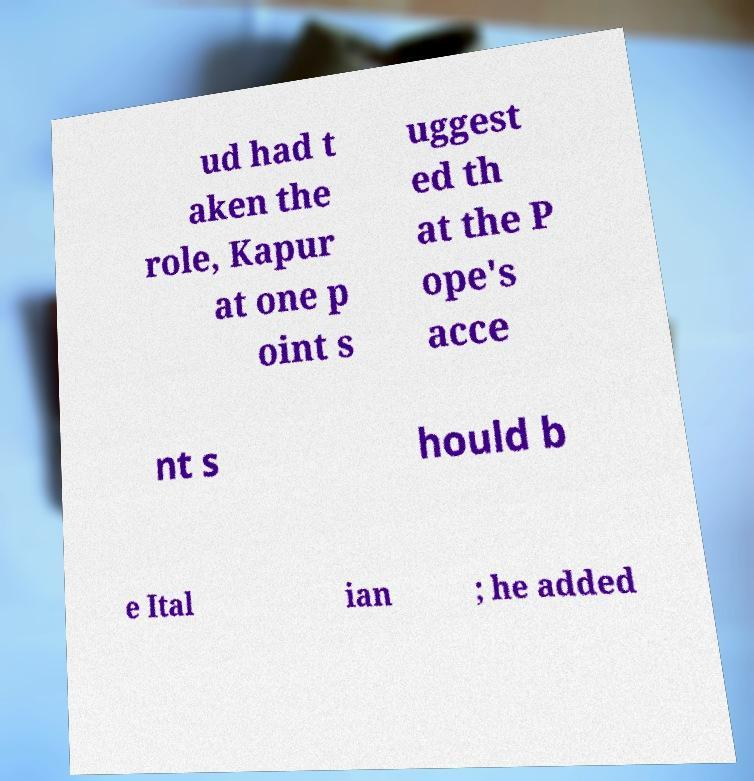Could you assist in decoding the text presented in this image and type it out clearly? ud had t aken the role, Kapur at one p oint s uggest ed th at the P ope's acce nt s hould b e Ital ian ; he added 